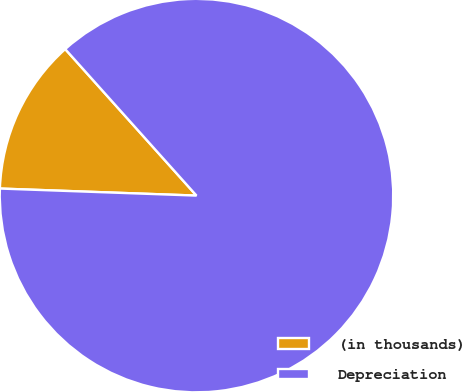Convert chart. <chart><loc_0><loc_0><loc_500><loc_500><pie_chart><fcel>(in thousands)<fcel>Depreciation<nl><fcel>12.8%<fcel>87.2%<nl></chart> 